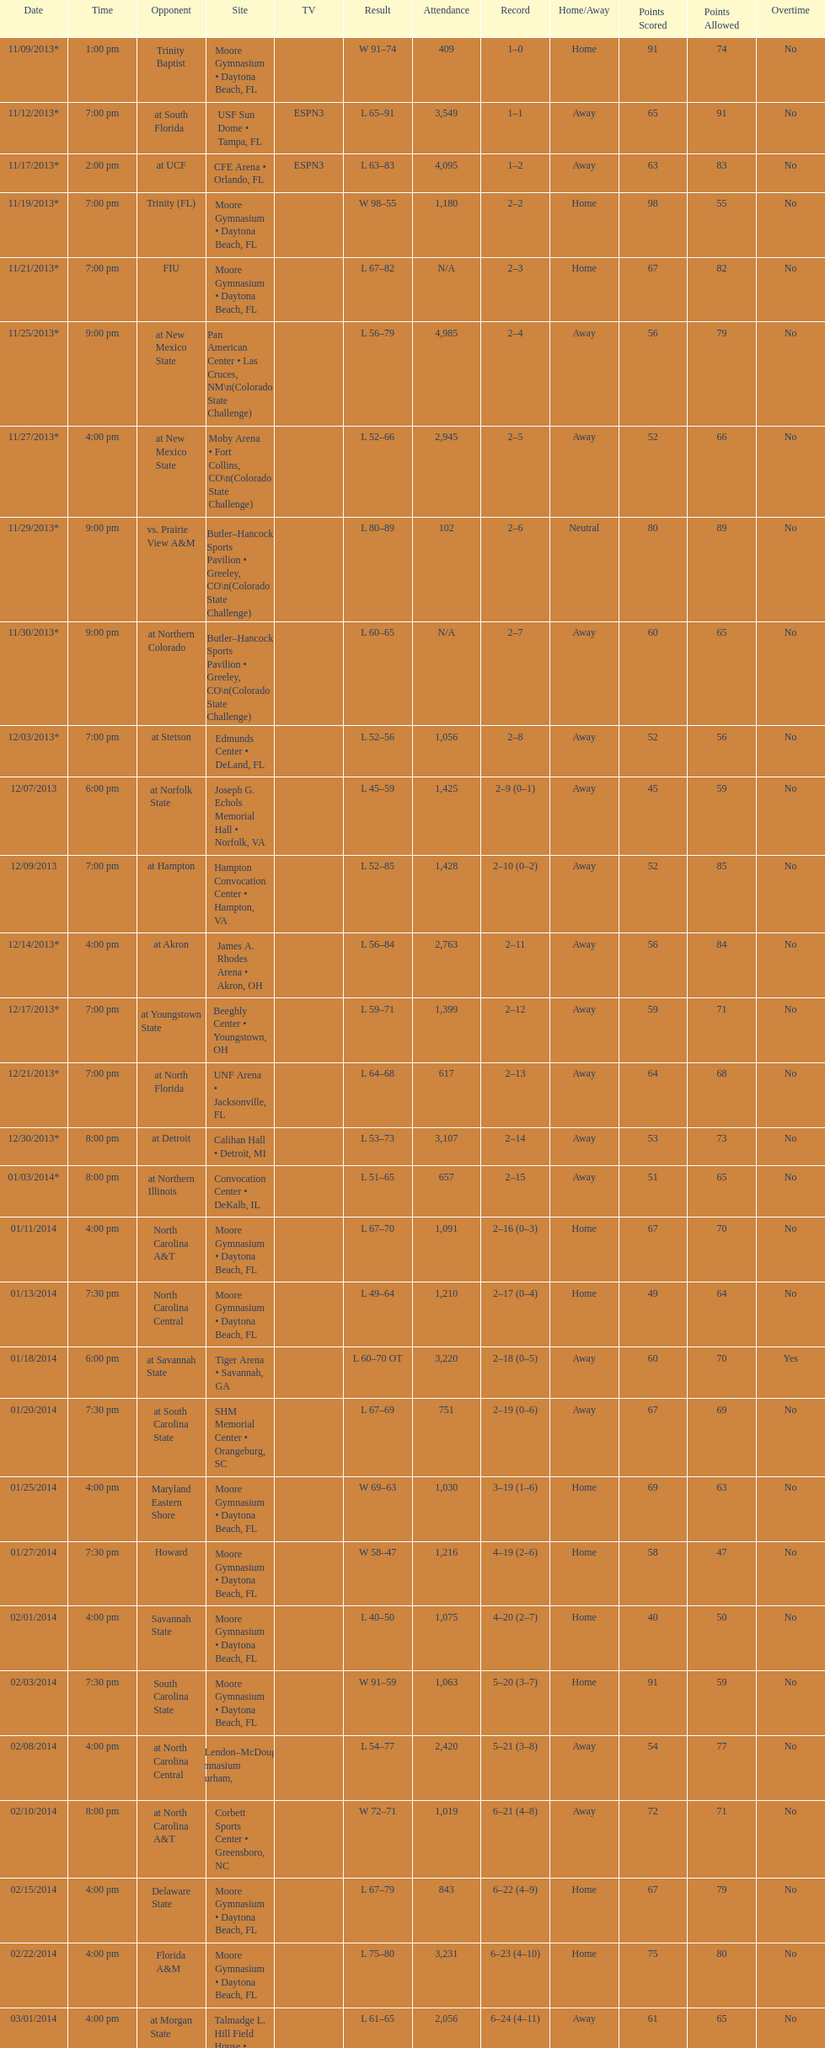What is the total attendance on 11/09/2013? 409. 